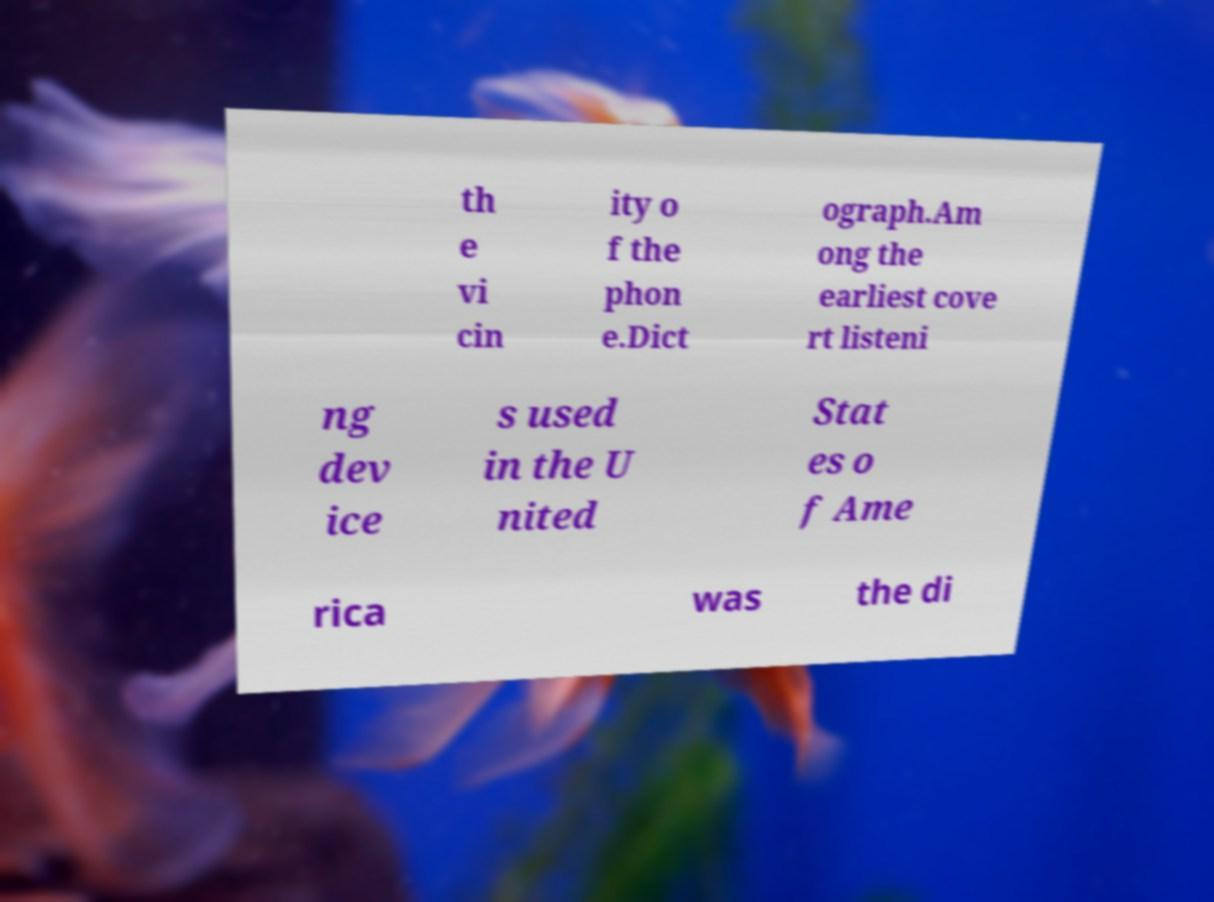Can you read and provide the text displayed in the image?This photo seems to have some interesting text. Can you extract and type it out for me? th e vi cin ity o f the phon e.Dict ograph.Am ong the earliest cove rt listeni ng dev ice s used in the U nited Stat es o f Ame rica was the di 